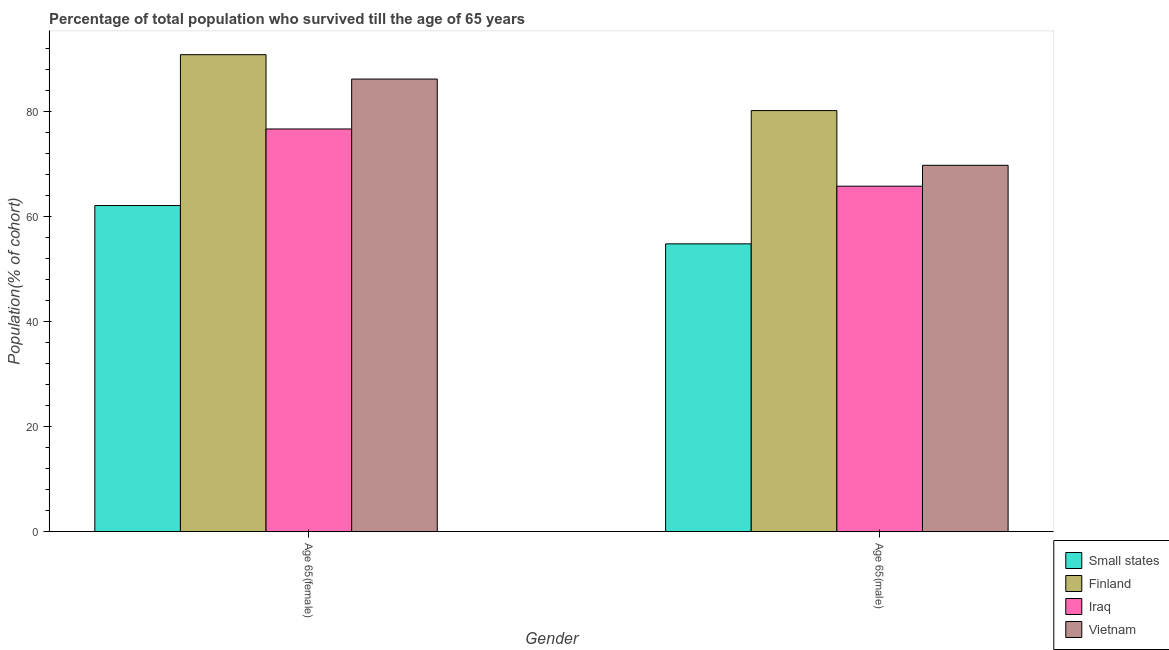How many different coloured bars are there?
Offer a very short reply. 4. Are the number of bars on each tick of the X-axis equal?
Your answer should be very brief. Yes. How many bars are there on the 1st tick from the left?
Make the answer very short. 4. How many bars are there on the 1st tick from the right?
Provide a short and direct response. 4. What is the label of the 1st group of bars from the left?
Provide a short and direct response. Age 65(female). What is the percentage of male population who survived till age of 65 in Small states?
Your answer should be compact. 54.84. Across all countries, what is the maximum percentage of female population who survived till age of 65?
Ensure brevity in your answer.  90.88. Across all countries, what is the minimum percentage of male population who survived till age of 65?
Keep it short and to the point. 54.84. In which country was the percentage of male population who survived till age of 65 maximum?
Keep it short and to the point. Finland. In which country was the percentage of male population who survived till age of 65 minimum?
Keep it short and to the point. Small states. What is the total percentage of male population who survived till age of 65 in the graph?
Offer a very short reply. 270.68. What is the difference between the percentage of female population who survived till age of 65 in Small states and that in Iraq?
Give a very brief answer. -14.59. What is the difference between the percentage of male population who survived till age of 65 in Finland and the percentage of female population who survived till age of 65 in Small states?
Your answer should be very brief. 18.09. What is the average percentage of female population who survived till age of 65 per country?
Offer a very short reply. 78.99. What is the difference between the percentage of female population who survived till age of 65 and percentage of male population who survived till age of 65 in Vietnam?
Keep it short and to the point. 16.43. In how many countries, is the percentage of male population who survived till age of 65 greater than 36 %?
Make the answer very short. 4. What is the ratio of the percentage of female population who survived till age of 65 in Small states to that in Vietnam?
Your answer should be compact. 0.72. In how many countries, is the percentage of female population who survived till age of 65 greater than the average percentage of female population who survived till age of 65 taken over all countries?
Give a very brief answer. 2. What does the 3rd bar from the left in Age 65(female) represents?
Your answer should be compact. Iraq. What does the 2nd bar from the right in Age 65(male) represents?
Provide a succinct answer. Iraq. How many countries are there in the graph?
Keep it short and to the point. 4. What is the difference between two consecutive major ticks on the Y-axis?
Give a very brief answer. 20. Are the values on the major ticks of Y-axis written in scientific E-notation?
Your answer should be compact. No. Does the graph contain any zero values?
Offer a terse response. No. Where does the legend appear in the graph?
Your response must be concise. Bottom right. How many legend labels are there?
Your answer should be very brief. 4. How are the legend labels stacked?
Make the answer very short. Vertical. What is the title of the graph?
Your response must be concise. Percentage of total population who survived till the age of 65 years. Does "Sweden" appear as one of the legend labels in the graph?
Make the answer very short. No. What is the label or title of the Y-axis?
Your answer should be very brief. Population(% of cohort). What is the Population(% of cohort) in Small states in Age 65(female)?
Provide a succinct answer. 62.14. What is the Population(% of cohort) of Finland in Age 65(female)?
Your response must be concise. 90.88. What is the Population(% of cohort) in Iraq in Age 65(female)?
Offer a terse response. 76.72. What is the Population(% of cohort) in Vietnam in Age 65(female)?
Your response must be concise. 86.23. What is the Population(% of cohort) of Small states in Age 65(male)?
Provide a succinct answer. 54.84. What is the Population(% of cohort) of Finland in Age 65(male)?
Your answer should be very brief. 80.22. What is the Population(% of cohort) of Iraq in Age 65(male)?
Make the answer very short. 65.82. What is the Population(% of cohort) of Vietnam in Age 65(male)?
Keep it short and to the point. 69.8. Across all Gender, what is the maximum Population(% of cohort) of Small states?
Offer a terse response. 62.14. Across all Gender, what is the maximum Population(% of cohort) of Finland?
Give a very brief answer. 90.88. Across all Gender, what is the maximum Population(% of cohort) in Iraq?
Your answer should be very brief. 76.72. Across all Gender, what is the maximum Population(% of cohort) in Vietnam?
Offer a terse response. 86.23. Across all Gender, what is the minimum Population(% of cohort) of Small states?
Offer a terse response. 54.84. Across all Gender, what is the minimum Population(% of cohort) in Finland?
Offer a very short reply. 80.22. Across all Gender, what is the minimum Population(% of cohort) of Iraq?
Your answer should be compact. 65.82. Across all Gender, what is the minimum Population(% of cohort) in Vietnam?
Provide a succinct answer. 69.8. What is the total Population(% of cohort) in Small states in the graph?
Your answer should be very brief. 116.97. What is the total Population(% of cohort) in Finland in the graph?
Provide a succinct answer. 171.1. What is the total Population(% of cohort) of Iraq in the graph?
Make the answer very short. 142.54. What is the total Population(% of cohort) in Vietnam in the graph?
Offer a terse response. 156.03. What is the difference between the Population(% of cohort) of Small states in Age 65(female) and that in Age 65(male)?
Give a very brief answer. 7.3. What is the difference between the Population(% of cohort) in Finland in Age 65(female) and that in Age 65(male)?
Your response must be concise. 10.65. What is the difference between the Population(% of cohort) in Iraq in Age 65(female) and that in Age 65(male)?
Your response must be concise. 10.9. What is the difference between the Population(% of cohort) in Vietnam in Age 65(female) and that in Age 65(male)?
Make the answer very short. 16.43. What is the difference between the Population(% of cohort) in Small states in Age 65(female) and the Population(% of cohort) in Finland in Age 65(male)?
Your answer should be very brief. -18.09. What is the difference between the Population(% of cohort) of Small states in Age 65(female) and the Population(% of cohort) of Iraq in Age 65(male)?
Provide a succinct answer. -3.68. What is the difference between the Population(% of cohort) in Small states in Age 65(female) and the Population(% of cohort) in Vietnam in Age 65(male)?
Your answer should be very brief. -7.67. What is the difference between the Population(% of cohort) in Finland in Age 65(female) and the Population(% of cohort) in Iraq in Age 65(male)?
Your response must be concise. 25.06. What is the difference between the Population(% of cohort) in Finland in Age 65(female) and the Population(% of cohort) in Vietnam in Age 65(male)?
Make the answer very short. 21.07. What is the difference between the Population(% of cohort) of Iraq in Age 65(female) and the Population(% of cohort) of Vietnam in Age 65(male)?
Make the answer very short. 6.92. What is the average Population(% of cohort) in Small states per Gender?
Give a very brief answer. 58.49. What is the average Population(% of cohort) of Finland per Gender?
Offer a very short reply. 85.55. What is the average Population(% of cohort) of Iraq per Gender?
Ensure brevity in your answer.  71.27. What is the average Population(% of cohort) in Vietnam per Gender?
Give a very brief answer. 78.02. What is the difference between the Population(% of cohort) of Small states and Population(% of cohort) of Finland in Age 65(female)?
Give a very brief answer. -28.74. What is the difference between the Population(% of cohort) in Small states and Population(% of cohort) in Iraq in Age 65(female)?
Your response must be concise. -14.59. What is the difference between the Population(% of cohort) of Small states and Population(% of cohort) of Vietnam in Age 65(female)?
Give a very brief answer. -24.09. What is the difference between the Population(% of cohort) of Finland and Population(% of cohort) of Iraq in Age 65(female)?
Your answer should be compact. 14.15. What is the difference between the Population(% of cohort) in Finland and Population(% of cohort) in Vietnam in Age 65(female)?
Your answer should be compact. 4.65. What is the difference between the Population(% of cohort) of Iraq and Population(% of cohort) of Vietnam in Age 65(female)?
Keep it short and to the point. -9.51. What is the difference between the Population(% of cohort) of Small states and Population(% of cohort) of Finland in Age 65(male)?
Make the answer very short. -25.39. What is the difference between the Population(% of cohort) in Small states and Population(% of cohort) in Iraq in Age 65(male)?
Provide a short and direct response. -10.98. What is the difference between the Population(% of cohort) of Small states and Population(% of cohort) of Vietnam in Age 65(male)?
Your response must be concise. -14.97. What is the difference between the Population(% of cohort) of Finland and Population(% of cohort) of Iraq in Age 65(male)?
Offer a very short reply. 14.4. What is the difference between the Population(% of cohort) of Finland and Population(% of cohort) of Vietnam in Age 65(male)?
Offer a very short reply. 10.42. What is the difference between the Population(% of cohort) in Iraq and Population(% of cohort) in Vietnam in Age 65(male)?
Your answer should be compact. -3.98. What is the ratio of the Population(% of cohort) of Small states in Age 65(female) to that in Age 65(male)?
Keep it short and to the point. 1.13. What is the ratio of the Population(% of cohort) of Finland in Age 65(female) to that in Age 65(male)?
Ensure brevity in your answer.  1.13. What is the ratio of the Population(% of cohort) of Iraq in Age 65(female) to that in Age 65(male)?
Keep it short and to the point. 1.17. What is the ratio of the Population(% of cohort) in Vietnam in Age 65(female) to that in Age 65(male)?
Give a very brief answer. 1.24. What is the difference between the highest and the second highest Population(% of cohort) of Small states?
Make the answer very short. 7.3. What is the difference between the highest and the second highest Population(% of cohort) in Finland?
Provide a succinct answer. 10.65. What is the difference between the highest and the second highest Population(% of cohort) in Iraq?
Your answer should be very brief. 10.9. What is the difference between the highest and the second highest Population(% of cohort) in Vietnam?
Keep it short and to the point. 16.43. What is the difference between the highest and the lowest Population(% of cohort) in Small states?
Ensure brevity in your answer.  7.3. What is the difference between the highest and the lowest Population(% of cohort) of Finland?
Provide a short and direct response. 10.65. What is the difference between the highest and the lowest Population(% of cohort) in Iraq?
Make the answer very short. 10.9. What is the difference between the highest and the lowest Population(% of cohort) of Vietnam?
Keep it short and to the point. 16.43. 